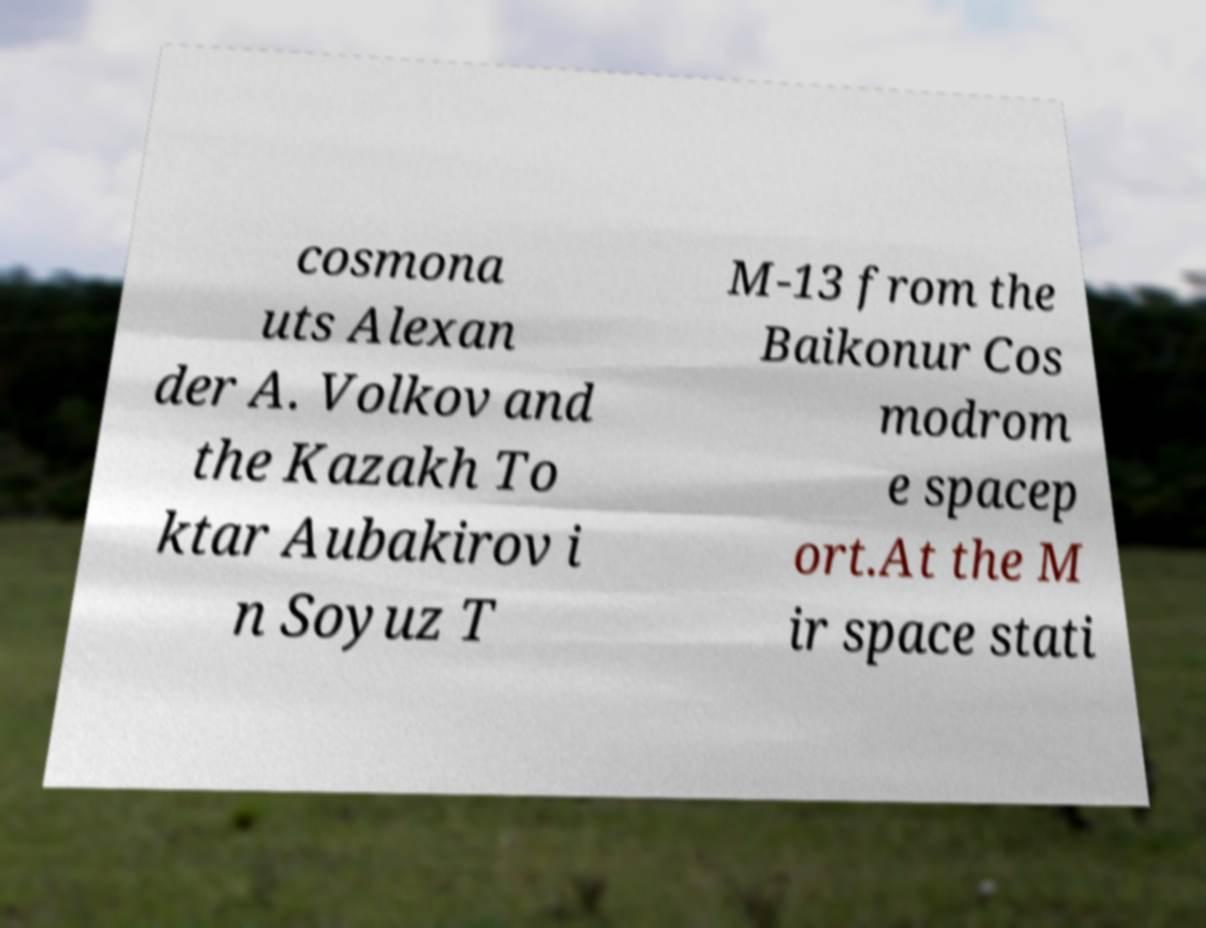Could you extract and type out the text from this image? cosmona uts Alexan der A. Volkov and the Kazakh To ktar Aubakirov i n Soyuz T M-13 from the Baikonur Cos modrom e spacep ort.At the M ir space stati 